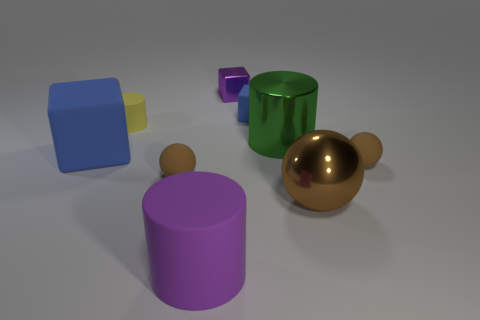Are there any other things that have the same color as the small cylinder?
Your response must be concise. No. How big is the green cylinder?
Ensure brevity in your answer.  Large. Are there more blue matte blocks that are behind the small yellow matte object than large shiny spheres in front of the large brown metallic ball?
Ensure brevity in your answer.  Yes. Are there any big green shiny things on the left side of the large purple cylinder?
Ensure brevity in your answer.  No. Are there any brown objects of the same size as the purple block?
Provide a succinct answer. Yes. There is a large cylinder that is made of the same material as the purple block; what color is it?
Give a very brief answer. Green. What material is the big ball?
Provide a succinct answer. Metal. What is the shape of the large green object?
Your answer should be compact. Cylinder. What number of big rubber blocks have the same color as the tiny rubber cube?
Your response must be concise. 1. What material is the big cylinder behind the tiny brown rubber ball left of the large metallic thing behind the big rubber block?
Keep it short and to the point. Metal. 